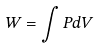<formula> <loc_0><loc_0><loc_500><loc_500>W = \int P d V</formula> 